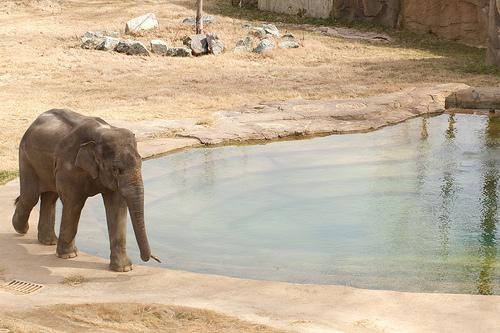Explain the primary focus of the image and how it impacts the scene. The primary focus is an elephant walking by a pond and holding a stick, and it adds a sense of tranquility and natural beauty to the scene. Describe the main elements of the image in a single sentence. The image features an elephant walking by a pond, carrying a stick with its trunk, with rocks, dry grass, and a stone wall nearby. Write a conversational description of the important features in the image. Hey, check out this elephant by the pond! It's carrying a stick with its trunk while walking past rocks, dry grass, and a cool stone wall. Provide a journalistic-style description of the scene in the image. In the enclosure, an elephant leisurely walks by a pond holding a stick with its trunk, creating a striking image amidst rocks, dry grass, and a stone wall backdrop. Write a brief narrative of the scene depicted in the image. An elephant ambles by the water's edge, gripping a stick in its long trunk, passing by rocks and dry grass as it navigates the landscape. Explain the overall mood and atmosphere of the image. The atmosphere of the image is tranquil and calming, as an elephant gracefully walks by a pond holding a stick while being surrounded by rocks, dry grass, and a stone wall. Mention the primary animal the image is focused on and what is happening around it. An elephant is walking next to a pond while holding a stick with its trunk, surrounded by rocks, dry grass, and a stone wall. List every significant object and event in the image. Elephant, walking, pond, holding stick, trunk, rocks, dry grass, stone wall, dead grass, drain gate, steps in water, shadow, metal drain gate. Give a poetic description of the image. Amidst the serene dance of nature's elements, an elephant gently strolls by a pond, grasping a stick in its majestic, curling trunk. Describe the main character and its actions in a story-like manner. Elegantly strolling along the path, the elephant gracefully carried a stick with its trunk as it passed a serene pond, a stone wall, and scattered rocks with tufts of dry grass. 